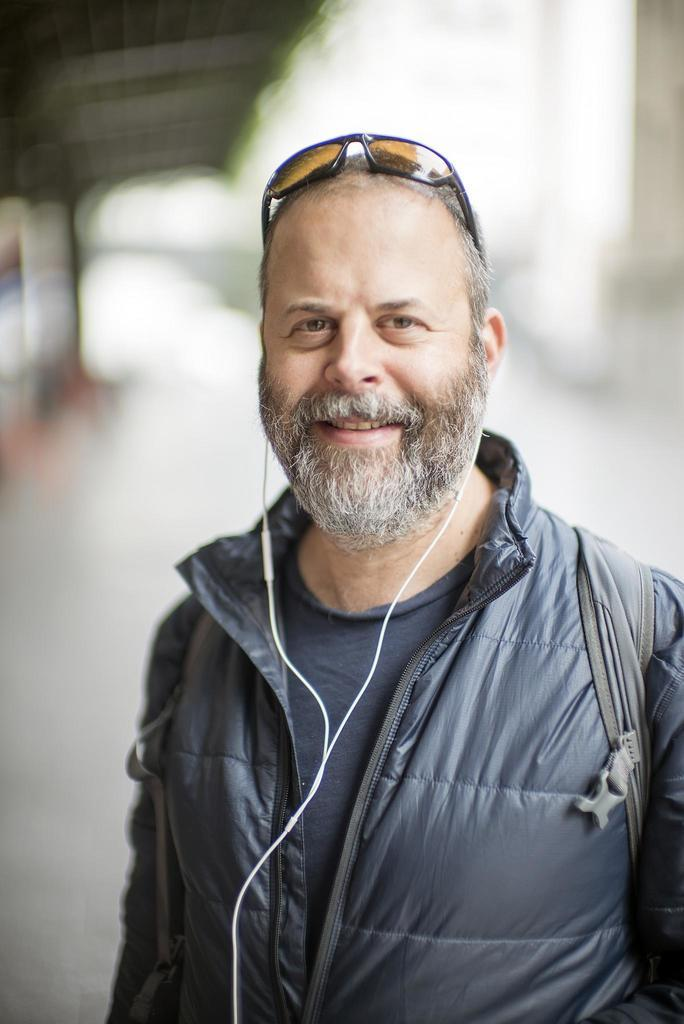What is the main subject of the image? There is a person in the image. What is the person wearing? The person is wearing a gray color jacket. Can you describe the person's accessories? The person is wearing a headset. What is the person's facial expression? The person is smiling. What is the person's posture in the image? The person is standing. How would you describe the background of the image? The background of the image is blurred. What type of trains can be seen in the person's thoughts in the image? There is no indication of trains or thoughts in the image; it only shows a person wearing a gray jacket, a headset, and standing with a smile. 